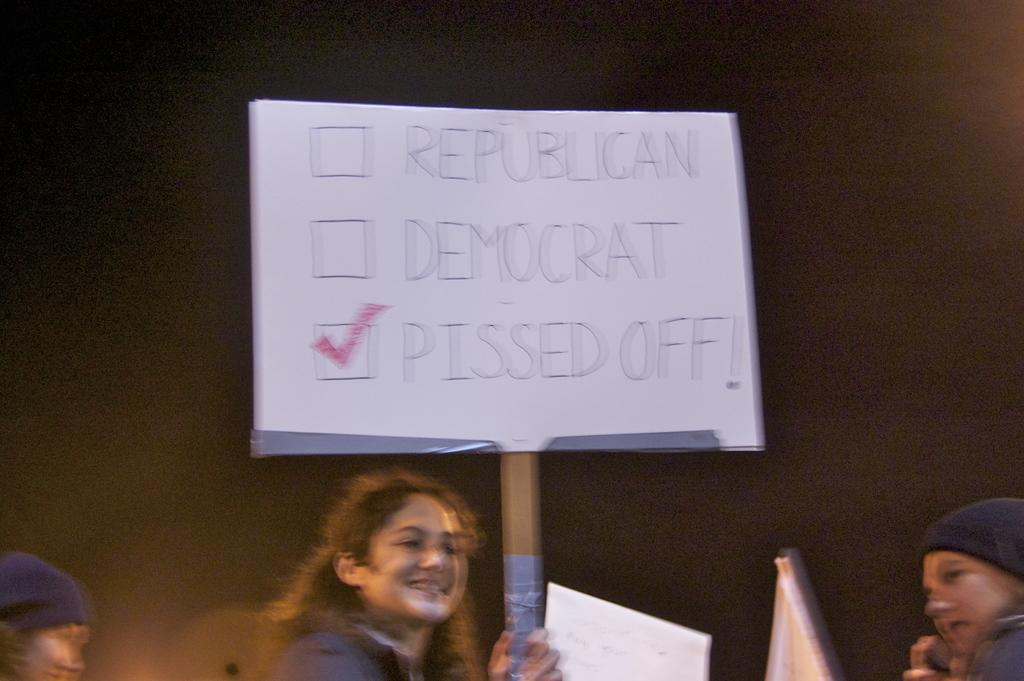How many people are present in the image? There are three people standing in the image. What is the woman holding in the image? The woman is holding a placard. What else can be seen in the image besides the people? There are boards visible in the image. What is the color of the background in the image? The background appears to be black in color. What type of lettuce is being sold at the downtown market in the image? There is no mention of lettuce or a downtown market in the image; it features three people and a woman holding a placard. What is the shared belief among the people in the image? There is no information about the people's beliefs in the image; they are simply standing together. 